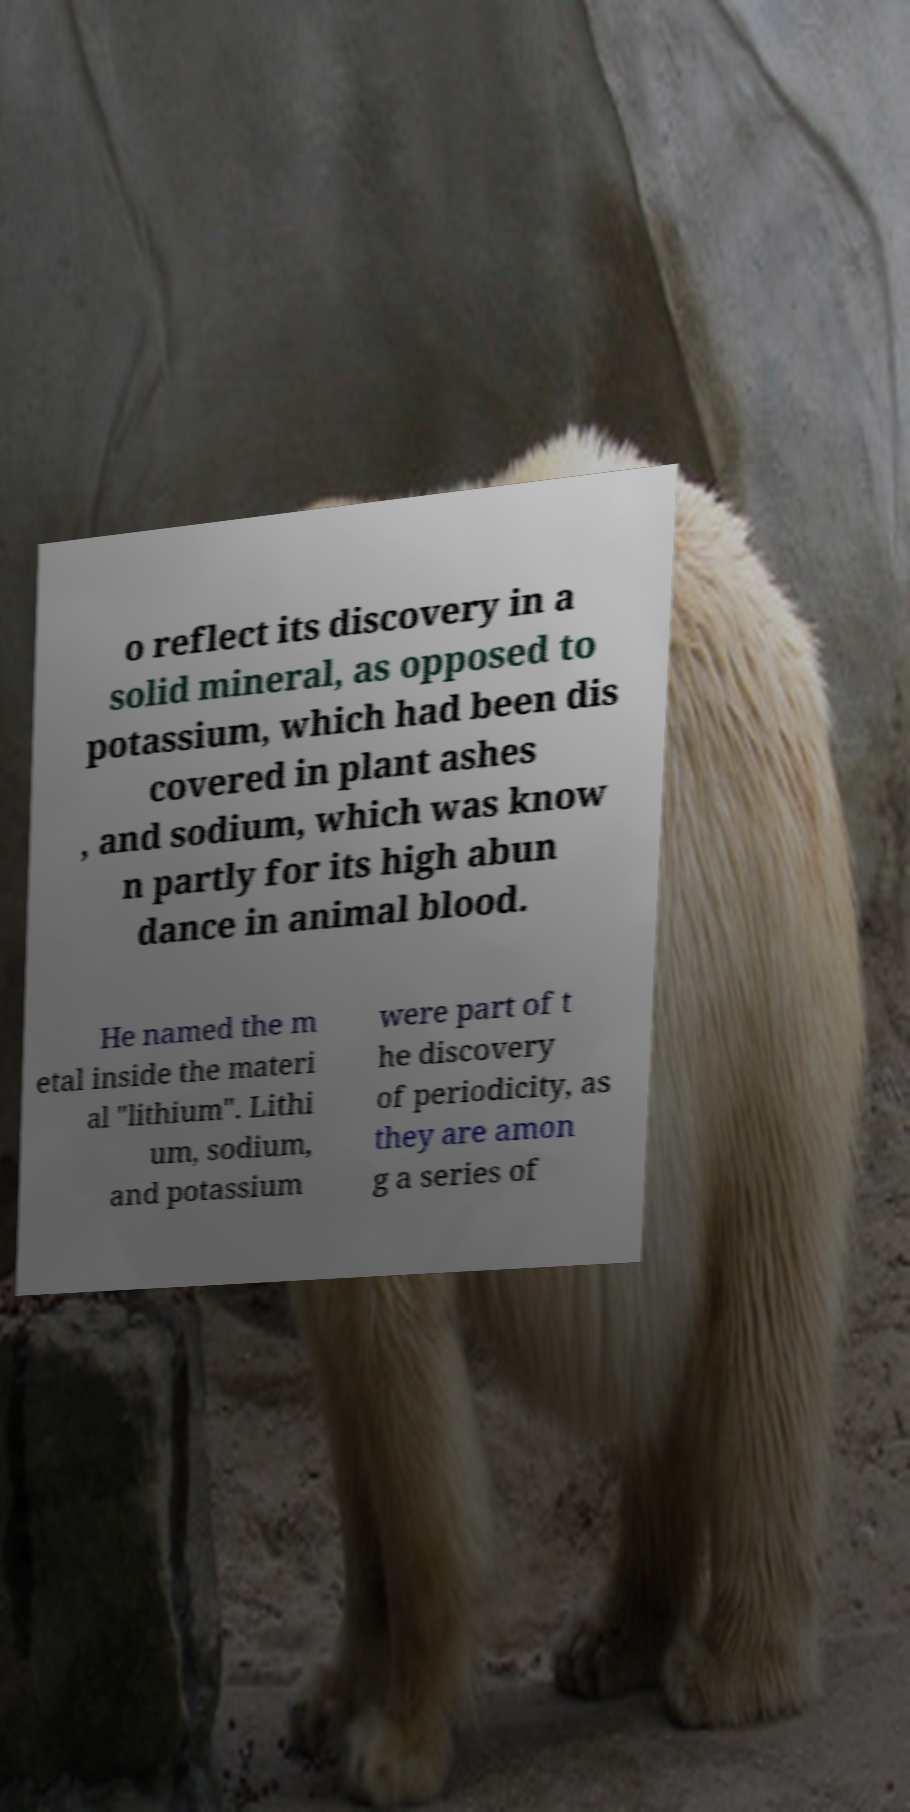Please read and relay the text visible in this image. What does it say? o reflect its discovery in a solid mineral, as opposed to potassium, which had been dis covered in plant ashes , and sodium, which was know n partly for its high abun dance in animal blood. He named the m etal inside the materi al "lithium". Lithi um, sodium, and potassium were part of t he discovery of periodicity, as they are amon g a series of 